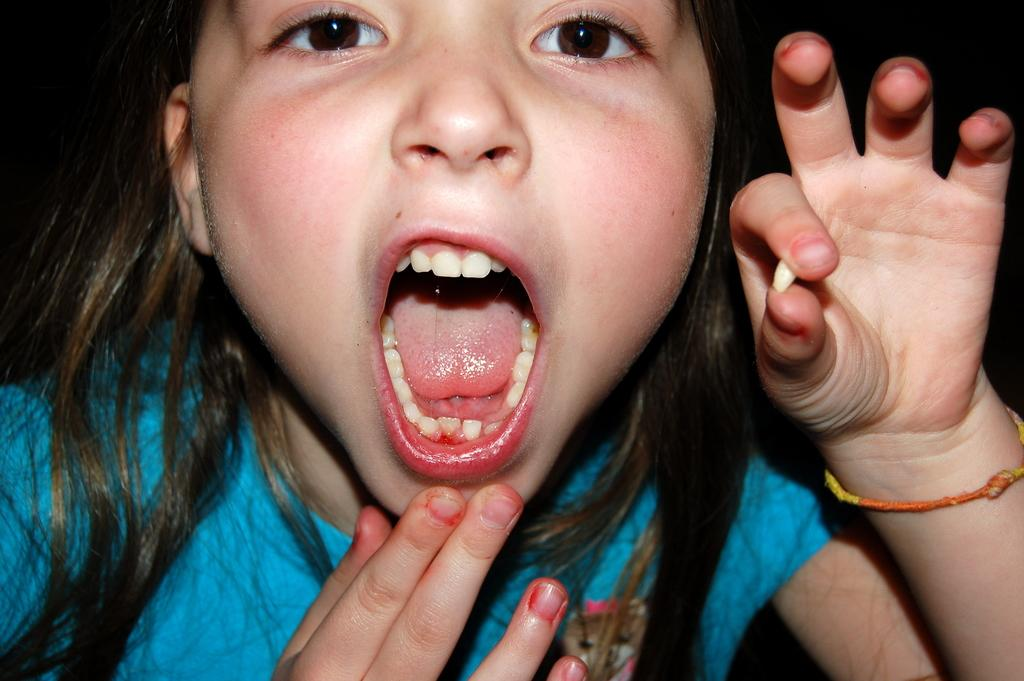Who is the main subject in the image? There is a girl in the image. What is the girl wearing? The girl is wearing a blue T-shirt. What is the girl doing with her mouth? The girl has opened her mouth. What is the girl holding in her hand? The girl is holding a tooth with two fingers of a hand. What can be observed about the background of the image? The background of the image is dark in color. What type of toothpaste is the girl using in the image? There is no toothpaste present in the image; the girl is holding a tooth with her fingers. How many women are visible in the image? There is only one girl visible in the image, not multiple women. 